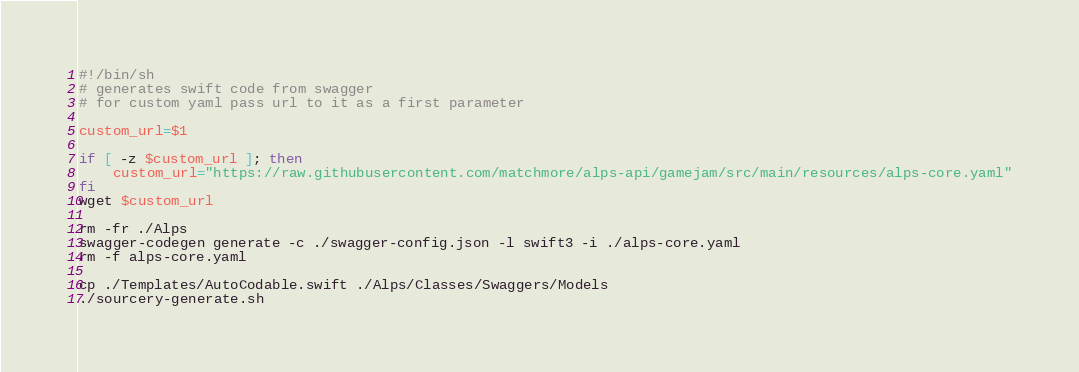<code> <loc_0><loc_0><loc_500><loc_500><_Bash_>#!/bin/sh
# generates swift code from swagger
# for custom yaml pass url to it as a first parameter

custom_url=$1

if [ -z $custom_url ]; then
    custom_url="https://raw.githubusercontent.com/matchmore/alps-api/gamejam/src/main/resources/alps-core.yaml"
fi
wget $custom_url

rm -fr ./Alps
swagger-codegen generate -c ./swagger-config.json -l swift3 -i ./alps-core.yaml
rm -f alps-core.yaml

cp ./Templates/AutoCodable.swift ./Alps/Classes/Swaggers/Models
./sourcery-generate.sh</code> 